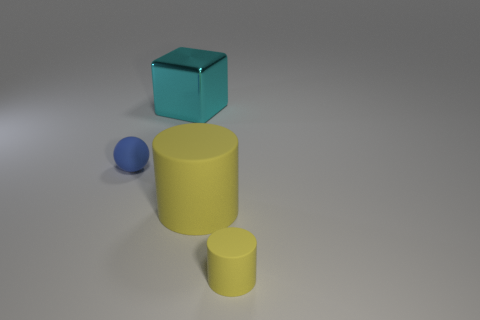Add 2 cyan objects. How many objects exist? 6 Subtract all balls. How many objects are left? 3 Subtract all purple spheres. Subtract all blue cylinders. How many spheres are left? 1 Subtract all purple metallic balls. Subtract all blue spheres. How many objects are left? 3 Add 2 small objects. How many small objects are left? 4 Add 3 large red cylinders. How many large red cylinders exist? 3 Subtract 0 brown cubes. How many objects are left? 4 